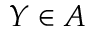<formula> <loc_0><loc_0><loc_500><loc_500>Y \in A</formula> 